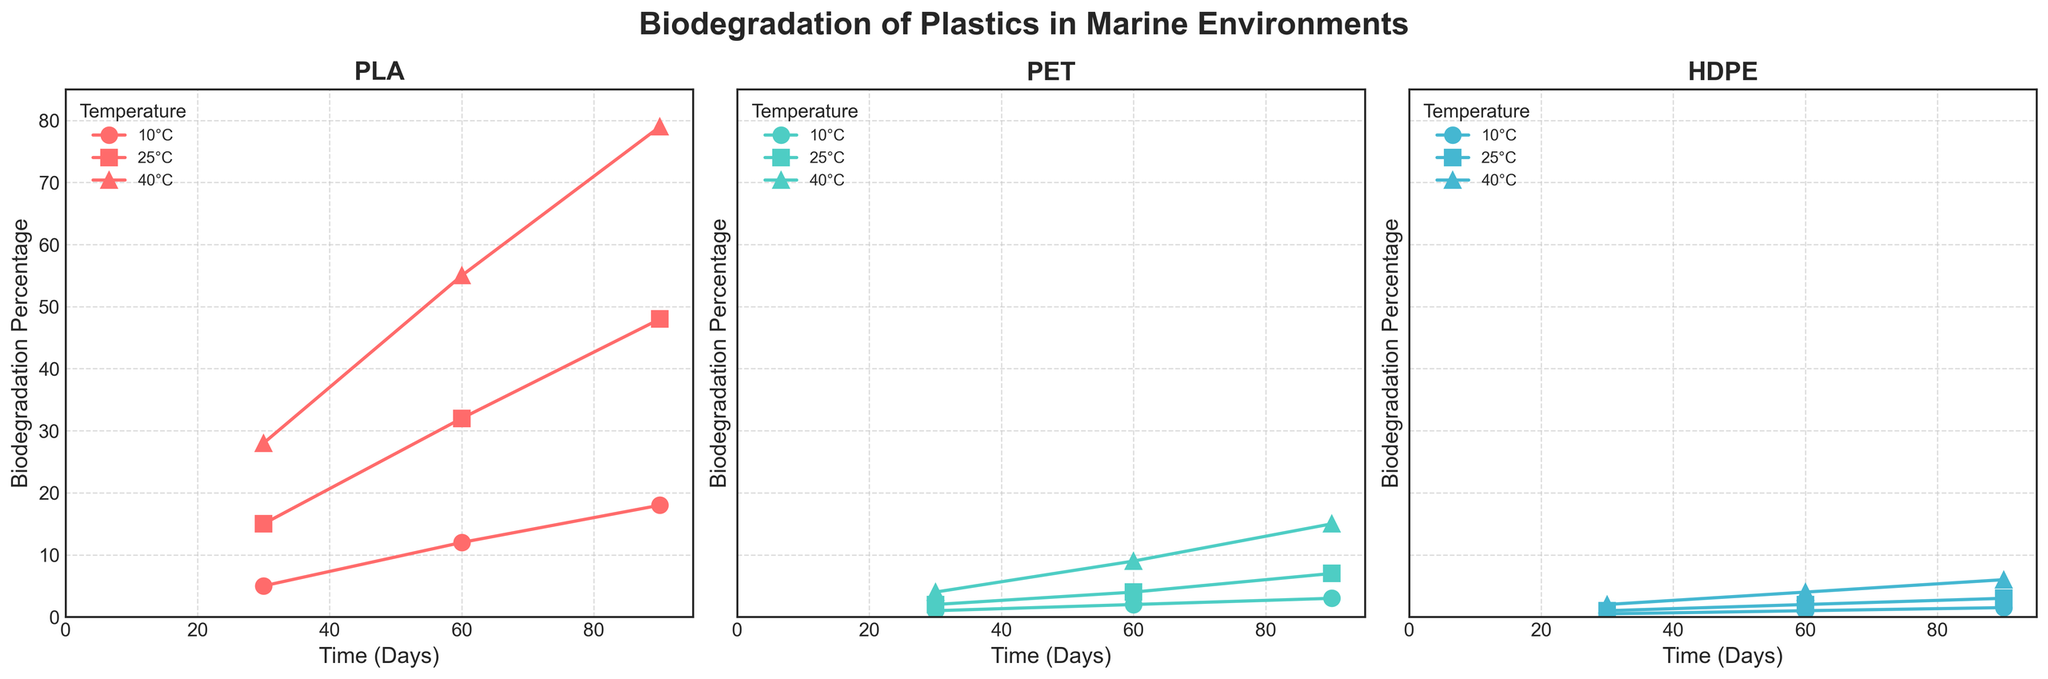What is the title of the figure? The title of the figure is displayed at the top and reads "Biodegradation of Plastics in Marine Environments".
Answer: Biodegradation of Plastics in Marine Environments Which plastic type shows the highest biodegradation percentage at 40°C on the 90th day? The highest biodegradation percentage at 40°C on the 90th day can be observed in the plot for PLA, where the percentage reaches 79%.
Answer: PLA How many temperature conditions are displayed for each plastic type? Each subplot for the plastic types (PLA, PET, HDPE) has three temperature conditions being displayed: 10°C, 25°C, and 40°C.
Answer: 3 What is the biodegradation percentage of HDPE at 10°C after 60 days? Referencing the HDPE subplot at the temperature condition of 10°C after 60 days, the biodegradation percentage is 1.
Answer: 1 Between PLA and PET, which plastic type biodegrades faster at 25°C over 60 days? To determine which plastic biodegrades faster, compare the biodegradation percentages at 25°C after 60 days for both PLA and PET. PLA reaches 32%, while PET reaches 4%. PLA biodegrades faster at 25°C over 60 days.
Answer: PLA Considering all temperature conditions, which plastic has the overall lowest biodegradation percentage at any given time? The PET subplot shows the lowest biodegradation percentages across all temperature conditions, with a maximum of only 15% at 40°C after 90 days.
Answer: PET How does the biodegradation percentage change for PLA at 25°C from 30 days to 60 days? The biodegradation percentage for PLA at 25°C increases from 15% at 30 days to 32% at 60 days.
Answer: It increases by 17% What is the average biodegradation percentage for HDPE at 40°C over the time points displayed? The biodegradation percentages for HDPE at 40°C are 2%, 4%, and 6% at 30, 60, and 90 days, respectively. Adding these up gives 12 and dividing by 3, we get an average of 4%.
Answer: 4% Which temperature condition results in the highest biodegradation percentage for PET? Examining the PET subplot, the highest biodegradation percentage is achieved at 40°C, with 15% at 90 days.
Answer: 40°C 